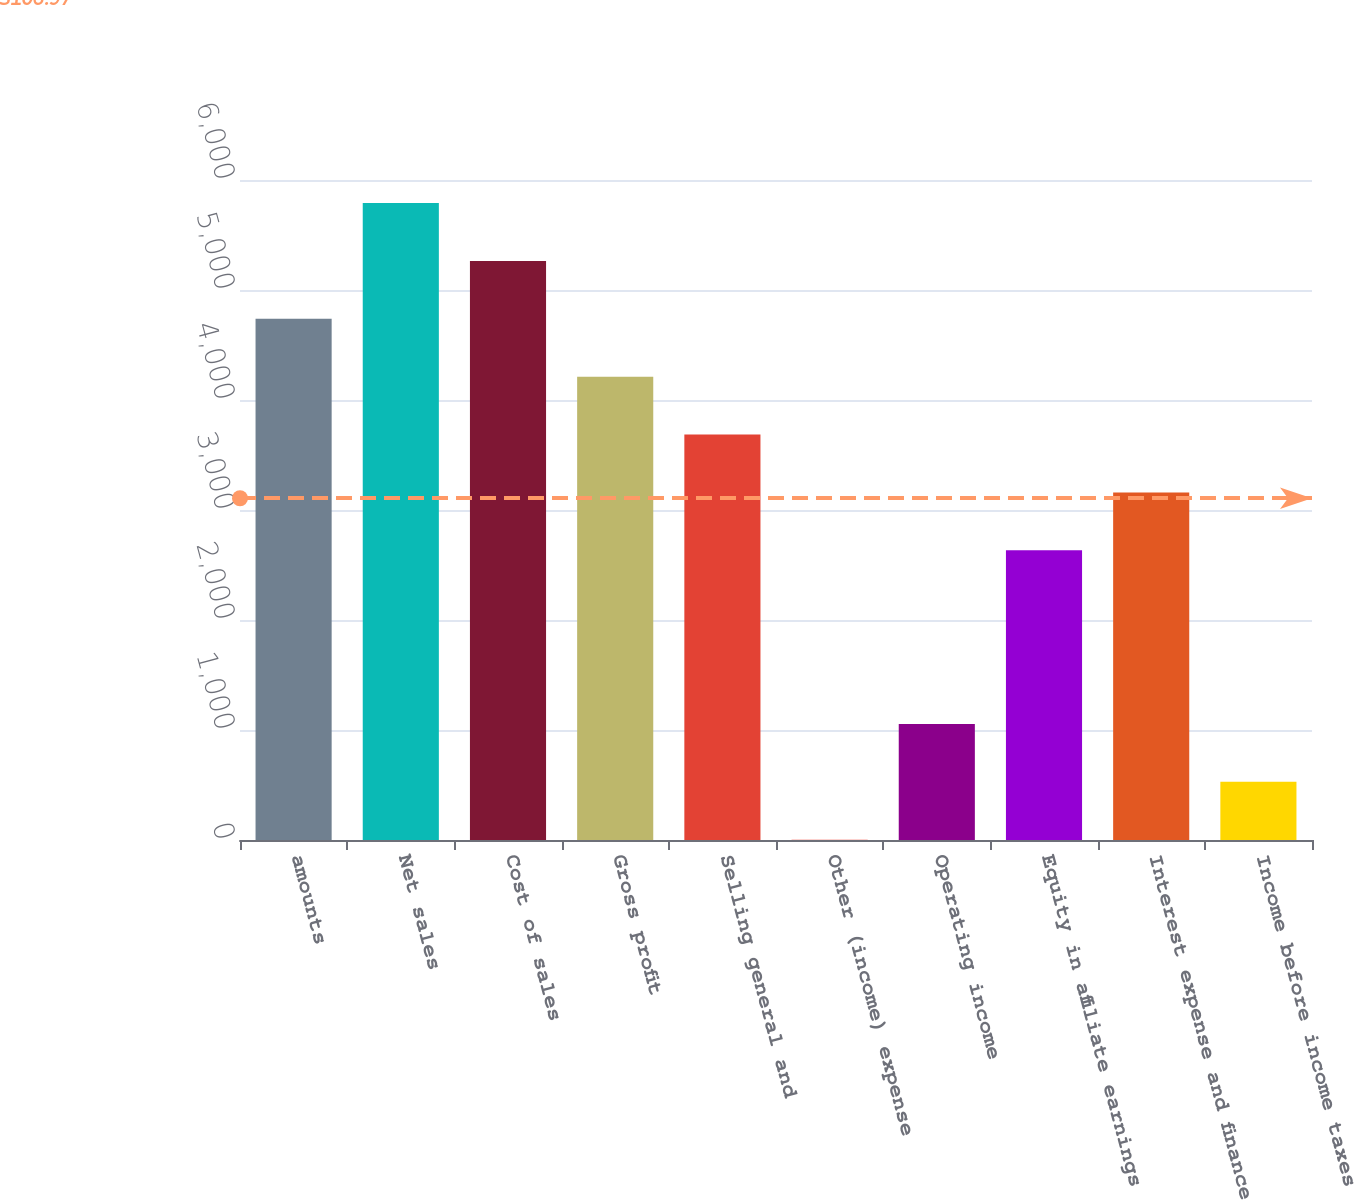Convert chart. <chart><loc_0><loc_0><loc_500><loc_500><bar_chart><fcel>amounts<fcel>Net sales<fcel>Cost of sales<fcel>Gross profit<fcel>Selling general and<fcel>Other (income) expense<fcel>Operating income<fcel>Equity in affiliate earnings<fcel>Interest expense and finance<fcel>Income before income taxes and<nl><fcel>4737.82<fcel>5789.98<fcel>5263.9<fcel>4211.74<fcel>3685.66<fcel>3.1<fcel>1055.26<fcel>2633.5<fcel>3159.58<fcel>529.18<nl></chart> 